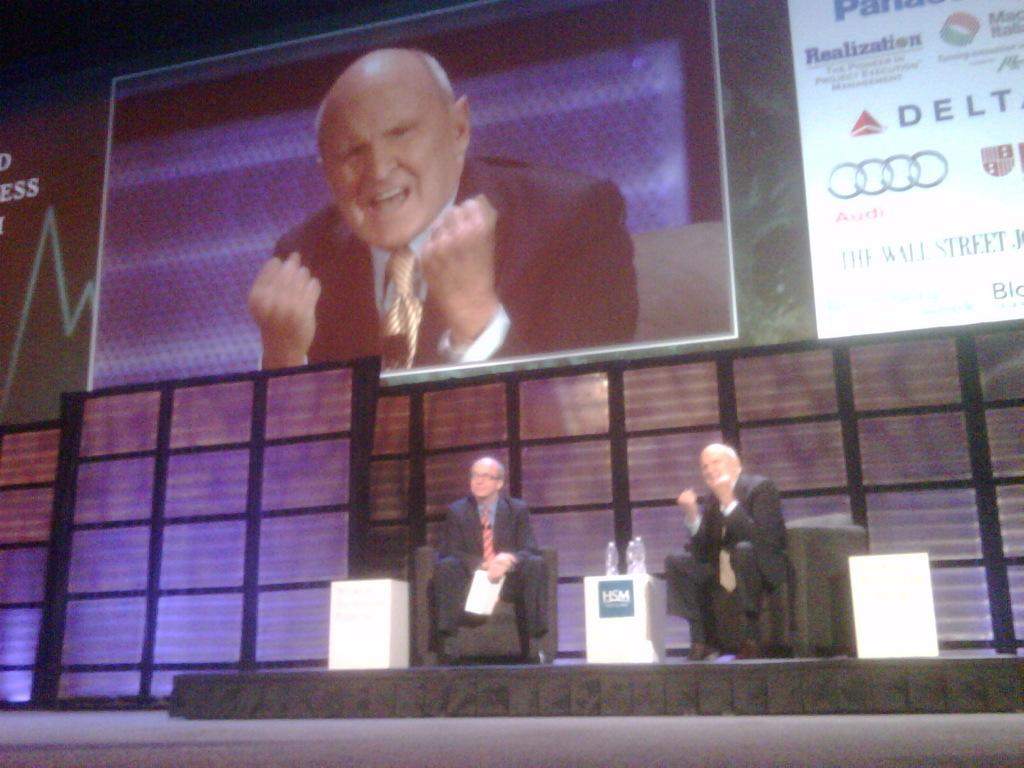How many people are sitting in the image? There are two people sitting on chairs in the image. What is located above the table in the image? There are bottles above a table in the image. What can be seen in the background of the image? There is a screen and hoardings in the background of the image. What is happening on the screen in the image? A person is visible on the screen in the image. What type of cakes are being served to the people sitting in the image? There is no indication of cakes being served in the image; the focus is on the people sitting, the bottles above the table, and the screen in the background. 